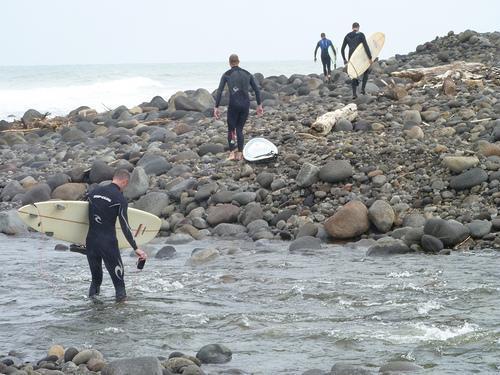How many people are there?
Give a very brief answer. 4. 